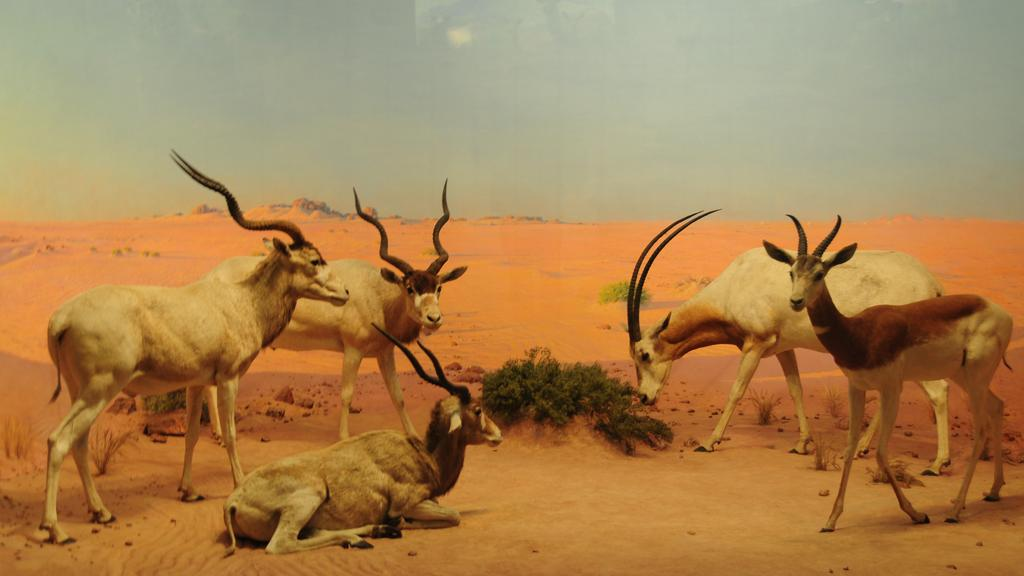What types of living organisms can be seen in the image? There are animals in the image. What is the ground surface like in the image? There is grass on the ground in the image. What part of the natural environment is visible in the image? The sky is visible in the background of the image. What type of wall can be seen in the image? There is no wall present in the image. How many curves can be seen in the image? There are no curves visible in the image. 